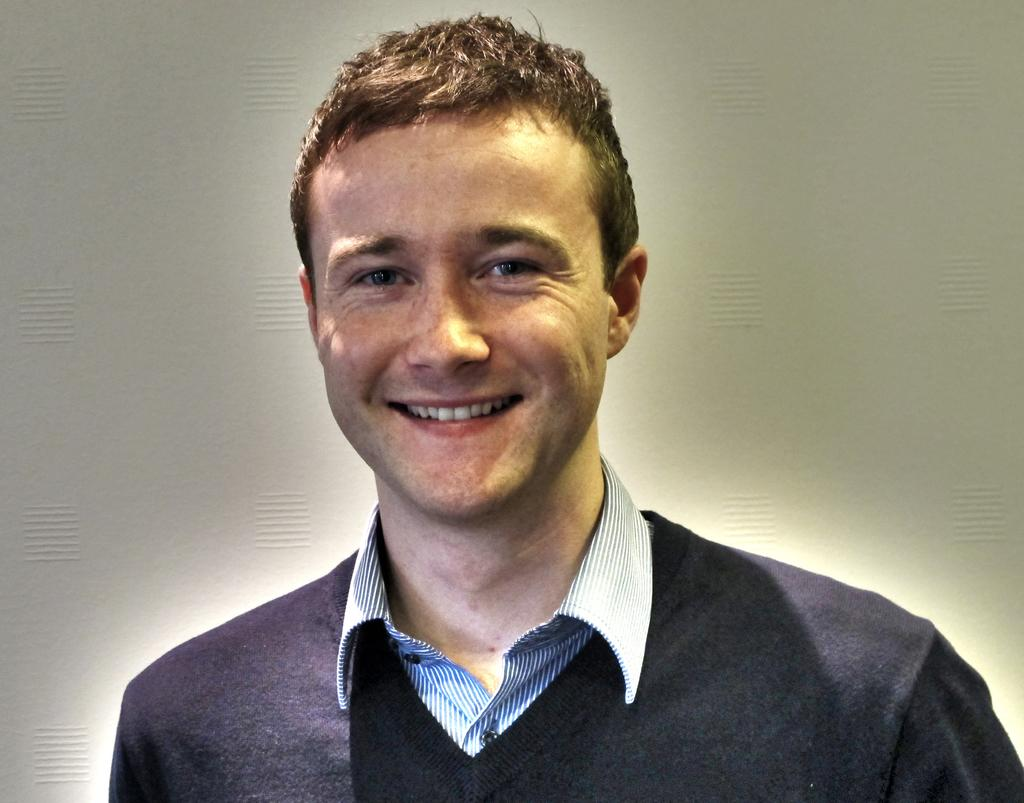What is the main subject of the image? There is a man in the image. What is the man doing in the image? The man is standing and smiling. What can be seen in the background of the image? There is a wall in the background of the image. What type of camp can be seen in the background of the image? There is no camp present in the image; it only features a man standing and smiling in front of a wall. What reward is the man holding in the image? There is no reward visible in the image; the man is simply standing and smiling. 